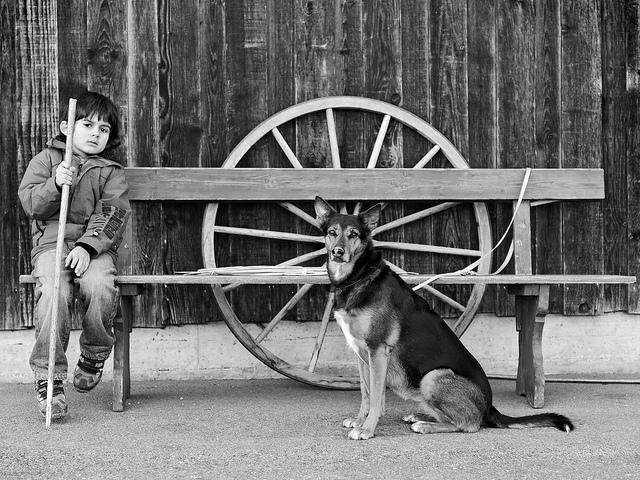What is the wheel called that's behind the bench? wagon wheel 